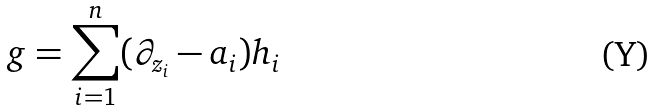Convert formula to latex. <formula><loc_0><loc_0><loc_500><loc_500>g = \sum _ { i = 1 } ^ { n } ( \partial _ { z _ { i } } - a _ { i } ) h _ { i }</formula> 